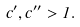<formula> <loc_0><loc_0><loc_500><loc_500>c ^ { \prime } , c ^ { \prime \prime } > 1 .</formula> 